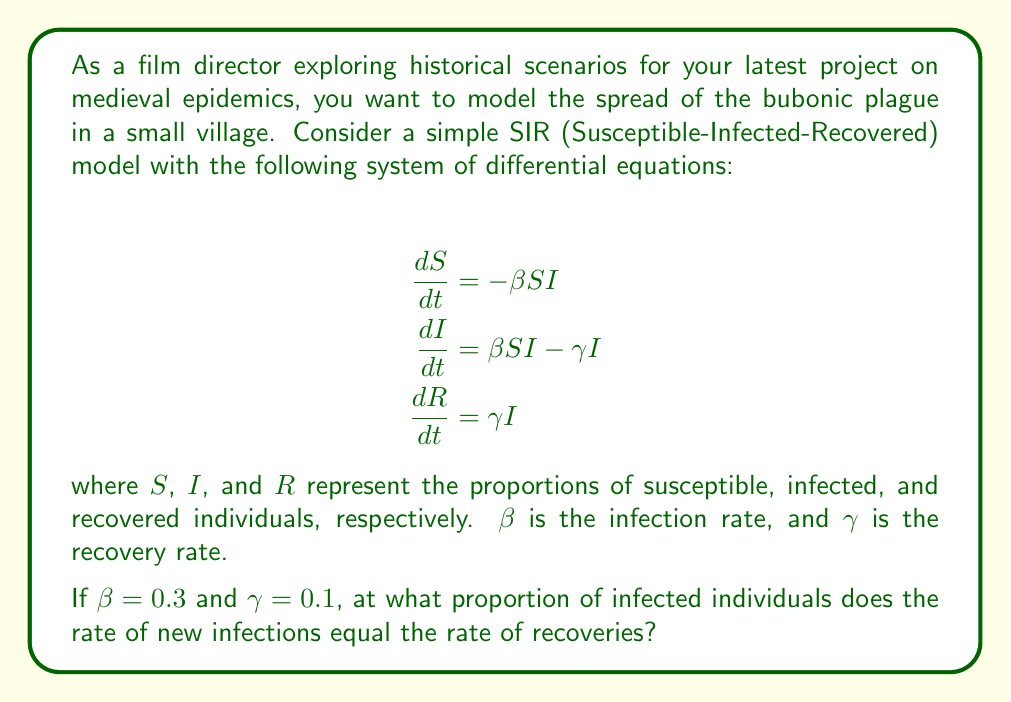Help me with this question. To solve this problem, we need to find the point where the rate of new infections equals the rate of recoveries. This occurs when $\frac{dI}{dt} = 0$.

1. Set $\frac{dI}{dt} = 0$:
   $$\beta SI - \gamma I = 0$$

2. Factor out $I$:
   $$I(\beta S - \gamma) = 0$$

3. Since we're interested in the non-zero solution (i.e., when there are infected individuals), we set:
   $$\beta S - \gamma = 0$$

4. Solve for $S$:
   $$S = \frac{\gamma}{\beta}$$

5. Substitute the given values:
   $$S = \frac{0.1}{0.3} = \frac{1}{3}$$

6. Since $S + I + R = 1$ (the total population), and we're looking for the proportion of infected individuals, we can calculate $I$ as:
   $$I = 1 - S - R$$

7. At this equilibrium point, $R$ is not changing, so we can consider it constant. Let's call it $R_0$. Then:
   $$I = 1 - \frac{1}{3} - R_0 = \frac{2}{3} - R_0$$

This equation represents the proportion of infected individuals at which the rate of new infections equals the rate of recoveries.
Answer: The rate of new infections equals the rate of recoveries when the proportion of infected individuals is $I = \frac{2}{3} - R_0$, where $R_0$ is the initial proportion of recovered individuals. 